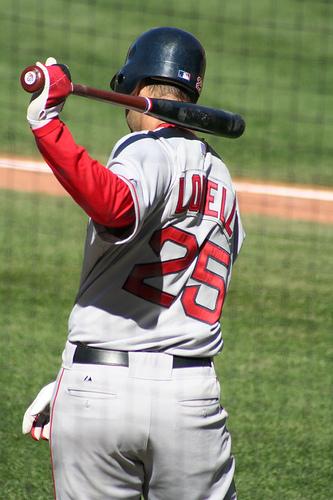What's the players number?
Answer briefly. 25. What number is on the man's shirt?
Short answer required. 25. What is the baseball player doing?
Quick response, please. Batting. What sport does he play?
Give a very brief answer. Baseball. 